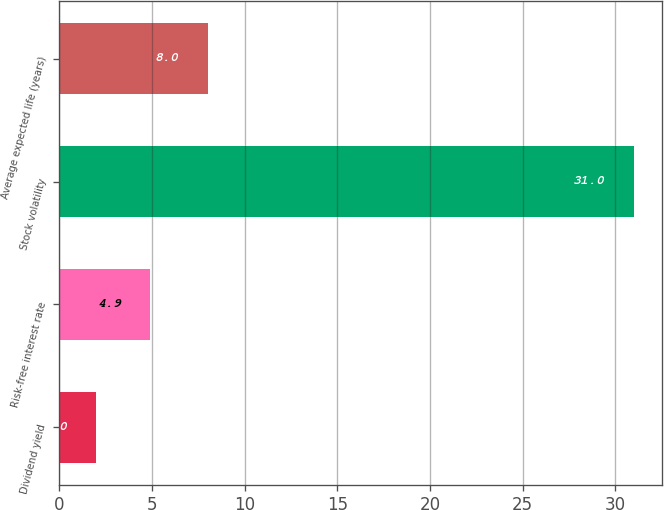Convert chart to OTSL. <chart><loc_0><loc_0><loc_500><loc_500><bar_chart><fcel>Dividend yield<fcel>Risk-free interest rate<fcel>Stock volatility<fcel>Average expected life (years)<nl><fcel>2<fcel>4.9<fcel>31<fcel>8<nl></chart> 